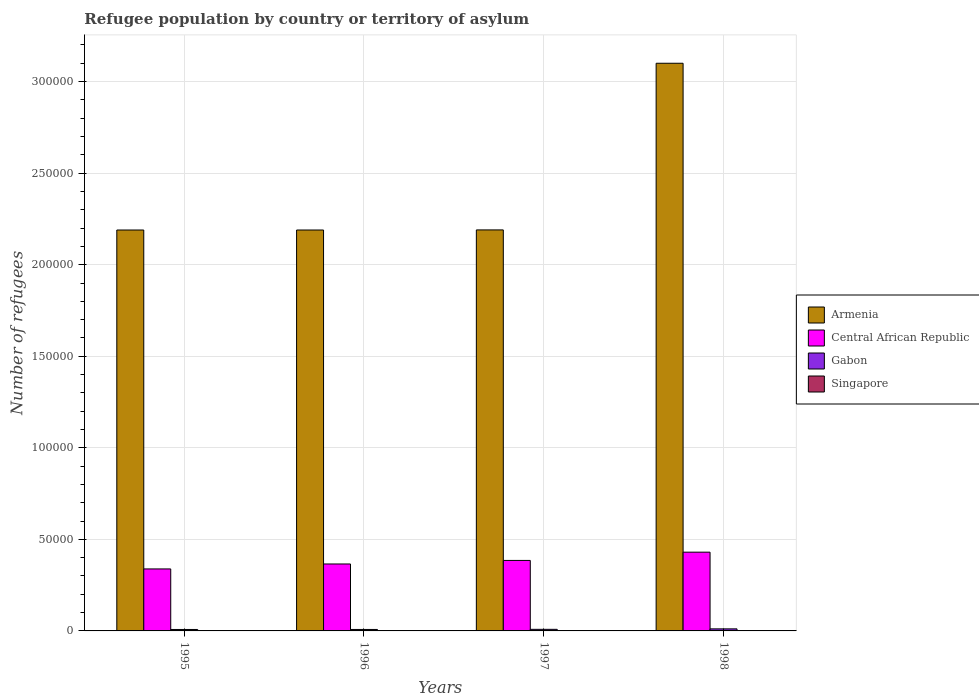How many bars are there on the 4th tick from the left?
Offer a very short reply. 4. What is the label of the 4th group of bars from the left?
Give a very brief answer. 1998. In how many cases, is the number of bars for a given year not equal to the number of legend labels?
Ensure brevity in your answer.  0. What is the number of refugees in Armenia in 1997?
Your response must be concise. 2.19e+05. Across all years, what is the maximum number of refugees in Central African Republic?
Provide a short and direct response. 4.30e+04. Across all years, what is the minimum number of refugees in Armenia?
Keep it short and to the point. 2.19e+05. What is the total number of refugees in Singapore in the graph?
Keep it short and to the point. 132. What is the difference between the number of refugees in Armenia in 1998 and the number of refugees in Central African Republic in 1995?
Ensure brevity in your answer.  2.76e+05. What is the average number of refugees in Armenia per year?
Make the answer very short. 2.42e+05. In the year 1997, what is the difference between the number of refugees in Armenia and number of refugees in Gabon?
Your response must be concise. 2.18e+05. What is the ratio of the number of refugees in Gabon in 1997 to that in 1998?
Offer a very short reply. 0.77. Is the number of refugees in Armenia in 1995 less than that in 1997?
Give a very brief answer. Yes. What is the difference between the highest and the second highest number of refugees in Gabon?
Offer a terse response. 262. What is the difference between the highest and the lowest number of refugees in Singapore?
Provide a succinct answer. 107. In how many years, is the number of refugees in Central African Republic greater than the average number of refugees in Central African Republic taken over all years?
Make the answer very short. 2. Is the sum of the number of refugees in Central African Republic in 1996 and 1998 greater than the maximum number of refugees in Gabon across all years?
Offer a very short reply. Yes. What does the 2nd bar from the left in 1998 represents?
Provide a short and direct response. Central African Republic. What does the 1st bar from the right in 1995 represents?
Keep it short and to the point. Singapore. Is it the case that in every year, the sum of the number of refugees in Central African Republic and number of refugees in Armenia is greater than the number of refugees in Singapore?
Ensure brevity in your answer.  Yes. How many bars are there?
Your response must be concise. 16. How many years are there in the graph?
Offer a very short reply. 4. Does the graph contain any zero values?
Offer a terse response. No. Does the graph contain grids?
Make the answer very short. Yes. What is the title of the graph?
Ensure brevity in your answer.  Refugee population by country or territory of asylum. What is the label or title of the Y-axis?
Offer a terse response. Number of refugees. What is the Number of refugees of Armenia in 1995?
Your response must be concise. 2.19e+05. What is the Number of refugees of Central African Republic in 1995?
Your response must be concise. 3.39e+04. What is the Number of refugees in Gabon in 1995?
Provide a succinct answer. 791. What is the Number of refugees of Singapore in 1995?
Your response must be concise. 112. What is the Number of refugees in Armenia in 1996?
Provide a succinct answer. 2.19e+05. What is the Number of refugees of Central African Republic in 1996?
Offer a terse response. 3.66e+04. What is the Number of refugees in Gabon in 1996?
Keep it short and to the point. 798. What is the Number of refugees of Singapore in 1996?
Provide a succinct answer. 10. What is the Number of refugees of Armenia in 1997?
Your answer should be very brief. 2.19e+05. What is the Number of refugees in Central African Republic in 1997?
Ensure brevity in your answer.  3.85e+04. What is the Number of refugees in Gabon in 1997?
Your answer should be compact. 862. What is the Number of refugees in Armenia in 1998?
Your answer should be compact. 3.10e+05. What is the Number of refugees of Central African Republic in 1998?
Provide a succinct answer. 4.30e+04. What is the Number of refugees of Gabon in 1998?
Offer a terse response. 1124. What is the Number of refugees of Singapore in 1998?
Your answer should be very brief. 5. Across all years, what is the maximum Number of refugees in Armenia?
Provide a succinct answer. 3.10e+05. Across all years, what is the maximum Number of refugees in Central African Republic?
Your answer should be compact. 4.30e+04. Across all years, what is the maximum Number of refugees of Gabon?
Keep it short and to the point. 1124. Across all years, what is the maximum Number of refugees in Singapore?
Your answer should be compact. 112. Across all years, what is the minimum Number of refugees of Armenia?
Make the answer very short. 2.19e+05. Across all years, what is the minimum Number of refugees in Central African Republic?
Provide a short and direct response. 3.39e+04. Across all years, what is the minimum Number of refugees in Gabon?
Your response must be concise. 791. What is the total Number of refugees of Armenia in the graph?
Provide a short and direct response. 9.67e+05. What is the total Number of refugees of Central African Republic in the graph?
Offer a terse response. 1.52e+05. What is the total Number of refugees of Gabon in the graph?
Keep it short and to the point. 3575. What is the total Number of refugees of Singapore in the graph?
Ensure brevity in your answer.  132. What is the difference between the Number of refugees in Central African Republic in 1995 and that in 1996?
Ensure brevity in your answer.  -2708. What is the difference between the Number of refugees in Gabon in 1995 and that in 1996?
Keep it short and to the point. -7. What is the difference between the Number of refugees in Singapore in 1995 and that in 1996?
Offer a terse response. 102. What is the difference between the Number of refugees in Armenia in 1995 and that in 1997?
Ensure brevity in your answer.  -50. What is the difference between the Number of refugees of Central African Republic in 1995 and that in 1997?
Your answer should be compact. -4643. What is the difference between the Number of refugees in Gabon in 1995 and that in 1997?
Your answer should be very brief. -71. What is the difference between the Number of refugees in Singapore in 1995 and that in 1997?
Your response must be concise. 107. What is the difference between the Number of refugees of Armenia in 1995 and that in 1998?
Ensure brevity in your answer.  -9.11e+04. What is the difference between the Number of refugees of Central African Republic in 1995 and that in 1998?
Offer a very short reply. -9157. What is the difference between the Number of refugees of Gabon in 1995 and that in 1998?
Provide a succinct answer. -333. What is the difference between the Number of refugees in Singapore in 1995 and that in 1998?
Offer a terse response. 107. What is the difference between the Number of refugees in Central African Republic in 1996 and that in 1997?
Your answer should be compact. -1935. What is the difference between the Number of refugees in Gabon in 1996 and that in 1997?
Give a very brief answer. -64. What is the difference between the Number of refugees of Armenia in 1996 and that in 1998?
Offer a very short reply. -9.11e+04. What is the difference between the Number of refugees in Central African Republic in 1996 and that in 1998?
Provide a short and direct response. -6449. What is the difference between the Number of refugees in Gabon in 1996 and that in 1998?
Your response must be concise. -326. What is the difference between the Number of refugees of Armenia in 1997 and that in 1998?
Your answer should be compact. -9.10e+04. What is the difference between the Number of refugees of Central African Republic in 1997 and that in 1998?
Provide a succinct answer. -4514. What is the difference between the Number of refugees of Gabon in 1997 and that in 1998?
Your response must be concise. -262. What is the difference between the Number of refugees of Armenia in 1995 and the Number of refugees of Central African Republic in 1996?
Your answer should be compact. 1.82e+05. What is the difference between the Number of refugees of Armenia in 1995 and the Number of refugees of Gabon in 1996?
Ensure brevity in your answer.  2.18e+05. What is the difference between the Number of refugees of Armenia in 1995 and the Number of refugees of Singapore in 1996?
Your answer should be compact. 2.19e+05. What is the difference between the Number of refugees of Central African Republic in 1995 and the Number of refugees of Gabon in 1996?
Offer a terse response. 3.31e+04. What is the difference between the Number of refugees in Central African Republic in 1995 and the Number of refugees in Singapore in 1996?
Give a very brief answer. 3.38e+04. What is the difference between the Number of refugees in Gabon in 1995 and the Number of refugees in Singapore in 1996?
Your answer should be very brief. 781. What is the difference between the Number of refugees in Armenia in 1995 and the Number of refugees in Central African Republic in 1997?
Keep it short and to the point. 1.80e+05. What is the difference between the Number of refugees in Armenia in 1995 and the Number of refugees in Gabon in 1997?
Your response must be concise. 2.18e+05. What is the difference between the Number of refugees of Armenia in 1995 and the Number of refugees of Singapore in 1997?
Your answer should be very brief. 2.19e+05. What is the difference between the Number of refugees in Central African Republic in 1995 and the Number of refugees in Gabon in 1997?
Offer a very short reply. 3.30e+04. What is the difference between the Number of refugees in Central African Republic in 1995 and the Number of refugees in Singapore in 1997?
Make the answer very short. 3.39e+04. What is the difference between the Number of refugees of Gabon in 1995 and the Number of refugees of Singapore in 1997?
Provide a succinct answer. 786. What is the difference between the Number of refugees of Armenia in 1995 and the Number of refugees of Central African Republic in 1998?
Your answer should be compact. 1.76e+05. What is the difference between the Number of refugees of Armenia in 1995 and the Number of refugees of Gabon in 1998?
Your answer should be compact. 2.18e+05. What is the difference between the Number of refugees of Armenia in 1995 and the Number of refugees of Singapore in 1998?
Offer a very short reply. 2.19e+05. What is the difference between the Number of refugees of Central African Republic in 1995 and the Number of refugees of Gabon in 1998?
Make the answer very short. 3.27e+04. What is the difference between the Number of refugees in Central African Republic in 1995 and the Number of refugees in Singapore in 1998?
Ensure brevity in your answer.  3.39e+04. What is the difference between the Number of refugees in Gabon in 1995 and the Number of refugees in Singapore in 1998?
Provide a succinct answer. 786. What is the difference between the Number of refugees in Armenia in 1996 and the Number of refugees in Central African Republic in 1997?
Your response must be concise. 1.80e+05. What is the difference between the Number of refugees in Armenia in 1996 and the Number of refugees in Gabon in 1997?
Provide a succinct answer. 2.18e+05. What is the difference between the Number of refugees of Armenia in 1996 and the Number of refugees of Singapore in 1997?
Your response must be concise. 2.19e+05. What is the difference between the Number of refugees in Central African Republic in 1996 and the Number of refugees in Gabon in 1997?
Offer a terse response. 3.57e+04. What is the difference between the Number of refugees of Central African Republic in 1996 and the Number of refugees of Singapore in 1997?
Ensure brevity in your answer.  3.66e+04. What is the difference between the Number of refugees in Gabon in 1996 and the Number of refugees in Singapore in 1997?
Your answer should be compact. 793. What is the difference between the Number of refugees of Armenia in 1996 and the Number of refugees of Central African Republic in 1998?
Provide a succinct answer. 1.76e+05. What is the difference between the Number of refugees in Armenia in 1996 and the Number of refugees in Gabon in 1998?
Ensure brevity in your answer.  2.18e+05. What is the difference between the Number of refugees in Armenia in 1996 and the Number of refugees in Singapore in 1998?
Your answer should be compact. 2.19e+05. What is the difference between the Number of refugees of Central African Republic in 1996 and the Number of refugees of Gabon in 1998?
Your answer should be compact. 3.54e+04. What is the difference between the Number of refugees of Central African Republic in 1996 and the Number of refugees of Singapore in 1998?
Give a very brief answer. 3.66e+04. What is the difference between the Number of refugees of Gabon in 1996 and the Number of refugees of Singapore in 1998?
Offer a very short reply. 793. What is the difference between the Number of refugees of Armenia in 1997 and the Number of refugees of Central African Republic in 1998?
Give a very brief answer. 1.76e+05. What is the difference between the Number of refugees in Armenia in 1997 and the Number of refugees in Gabon in 1998?
Ensure brevity in your answer.  2.18e+05. What is the difference between the Number of refugees of Armenia in 1997 and the Number of refugees of Singapore in 1998?
Your answer should be very brief. 2.19e+05. What is the difference between the Number of refugees of Central African Republic in 1997 and the Number of refugees of Gabon in 1998?
Keep it short and to the point. 3.74e+04. What is the difference between the Number of refugees of Central African Republic in 1997 and the Number of refugees of Singapore in 1998?
Your response must be concise. 3.85e+04. What is the difference between the Number of refugees in Gabon in 1997 and the Number of refugees in Singapore in 1998?
Provide a short and direct response. 857. What is the average Number of refugees in Armenia per year?
Provide a succinct answer. 2.42e+05. What is the average Number of refugees in Central African Republic per year?
Ensure brevity in your answer.  3.80e+04. What is the average Number of refugees in Gabon per year?
Offer a terse response. 893.75. What is the average Number of refugees of Singapore per year?
Your answer should be very brief. 33. In the year 1995, what is the difference between the Number of refugees in Armenia and Number of refugees in Central African Republic?
Your response must be concise. 1.85e+05. In the year 1995, what is the difference between the Number of refugees in Armenia and Number of refugees in Gabon?
Give a very brief answer. 2.18e+05. In the year 1995, what is the difference between the Number of refugees of Armenia and Number of refugees of Singapore?
Provide a short and direct response. 2.19e+05. In the year 1995, what is the difference between the Number of refugees of Central African Republic and Number of refugees of Gabon?
Offer a terse response. 3.31e+04. In the year 1995, what is the difference between the Number of refugees in Central African Republic and Number of refugees in Singapore?
Offer a very short reply. 3.37e+04. In the year 1995, what is the difference between the Number of refugees of Gabon and Number of refugees of Singapore?
Your answer should be very brief. 679. In the year 1996, what is the difference between the Number of refugees of Armenia and Number of refugees of Central African Republic?
Provide a short and direct response. 1.82e+05. In the year 1996, what is the difference between the Number of refugees in Armenia and Number of refugees in Gabon?
Provide a succinct answer. 2.18e+05. In the year 1996, what is the difference between the Number of refugees in Armenia and Number of refugees in Singapore?
Offer a terse response. 2.19e+05. In the year 1996, what is the difference between the Number of refugees in Central African Republic and Number of refugees in Gabon?
Offer a very short reply. 3.58e+04. In the year 1996, what is the difference between the Number of refugees in Central African Republic and Number of refugees in Singapore?
Give a very brief answer. 3.66e+04. In the year 1996, what is the difference between the Number of refugees in Gabon and Number of refugees in Singapore?
Your response must be concise. 788. In the year 1997, what is the difference between the Number of refugees in Armenia and Number of refugees in Central African Republic?
Your answer should be very brief. 1.81e+05. In the year 1997, what is the difference between the Number of refugees in Armenia and Number of refugees in Gabon?
Provide a short and direct response. 2.18e+05. In the year 1997, what is the difference between the Number of refugees in Armenia and Number of refugees in Singapore?
Give a very brief answer. 2.19e+05. In the year 1997, what is the difference between the Number of refugees of Central African Republic and Number of refugees of Gabon?
Offer a very short reply. 3.76e+04. In the year 1997, what is the difference between the Number of refugees of Central African Republic and Number of refugees of Singapore?
Make the answer very short. 3.85e+04. In the year 1997, what is the difference between the Number of refugees of Gabon and Number of refugees of Singapore?
Give a very brief answer. 857. In the year 1998, what is the difference between the Number of refugees in Armenia and Number of refugees in Central African Republic?
Provide a short and direct response. 2.67e+05. In the year 1998, what is the difference between the Number of refugees of Armenia and Number of refugees of Gabon?
Provide a succinct answer. 3.09e+05. In the year 1998, what is the difference between the Number of refugees in Armenia and Number of refugees in Singapore?
Provide a short and direct response. 3.10e+05. In the year 1998, what is the difference between the Number of refugees of Central African Republic and Number of refugees of Gabon?
Ensure brevity in your answer.  4.19e+04. In the year 1998, what is the difference between the Number of refugees of Central African Republic and Number of refugees of Singapore?
Offer a terse response. 4.30e+04. In the year 1998, what is the difference between the Number of refugees in Gabon and Number of refugees in Singapore?
Offer a terse response. 1119. What is the ratio of the Number of refugees of Armenia in 1995 to that in 1996?
Offer a very short reply. 1. What is the ratio of the Number of refugees of Central African Republic in 1995 to that in 1996?
Provide a succinct answer. 0.93. What is the ratio of the Number of refugees of Gabon in 1995 to that in 1996?
Your answer should be very brief. 0.99. What is the ratio of the Number of refugees in Central African Republic in 1995 to that in 1997?
Make the answer very short. 0.88. What is the ratio of the Number of refugees of Gabon in 1995 to that in 1997?
Your answer should be very brief. 0.92. What is the ratio of the Number of refugees of Singapore in 1995 to that in 1997?
Keep it short and to the point. 22.4. What is the ratio of the Number of refugees of Armenia in 1995 to that in 1998?
Your answer should be compact. 0.71. What is the ratio of the Number of refugees of Central African Republic in 1995 to that in 1998?
Keep it short and to the point. 0.79. What is the ratio of the Number of refugees in Gabon in 1995 to that in 1998?
Provide a short and direct response. 0.7. What is the ratio of the Number of refugees of Singapore in 1995 to that in 1998?
Provide a short and direct response. 22.4. What is the ratio of the Number of refugees of Armenia in 1996 to that in 1997?
Ensure brevity in your answer.  1. What is the ratio of the Number of refugees in Central African Republic in 1996 to that in 1997?
Your answer should be compact. 0.95. What is the ratio of the Number of refugees in Gabon in 1996 to that in 1997?
Your answer should be very brief. 0.93. What is the ratio of the Number of refugees in Singapore in 1996 to that in 1997?
Keep it short and to the point. 2. What is the ratio of the Number of refugees of Armenia in 1996 to that in 1998?
Make the answer very short. 0.71. What is the ratio of the Number of refugees in Central African Republic in 1996 to that in 1998?
Make the answer very short. 0.85. What is the ratio of the Number of refugees of Gabon in 1996 to that in 1998?
Keep it short and to the point. 0.71. What is the ratio of the Number of refugees of Armenia in 1997 to that in 1998?
Offer a very short reply. 0.71. What is the ratio of the Number of refugees in Central African Republic in 1997 to that in 1998?
Your answer should be compact. 0.9. What is the ratio of the Number of refugees in Gabon in 1997 to that in 1998?
Ensure brevity in your answer.  0.77. What is the ratio of the Number of refugees of Singapore in 1997 to that in 1998?
Provide a succinct answer. 1. What is the difference between the highest and the second highest Number of refugees of Armenia?
Give a very brief answer. 9.10e+04. What is the difference between the highest and the second highest Number of refugees in Central African Republic?
Offer a terse response. 4514. What is the difference between the highest and the second highest Number of refugees in Gabon?
Provide a short and direct response. 262. What is the difference between the highest and the second highest Number of refugees in Singapore?
Your response must be concise. 102. What is the difference between the highest and the lowest Number of refugees of Armenia?
Provide a succinct answer. 9.11e+04. What is the difference between the highest and the lowest Number of refugees in Central African Republic?
Provide a short and direct response. 9157. What is the difference between the highest and the lowest Number of refugees in Gabon?
Offer a very short reply. 333. What is the difference between the highest and the lowest Number of refugees of Singapore?
Give a very brief answer. 107. 